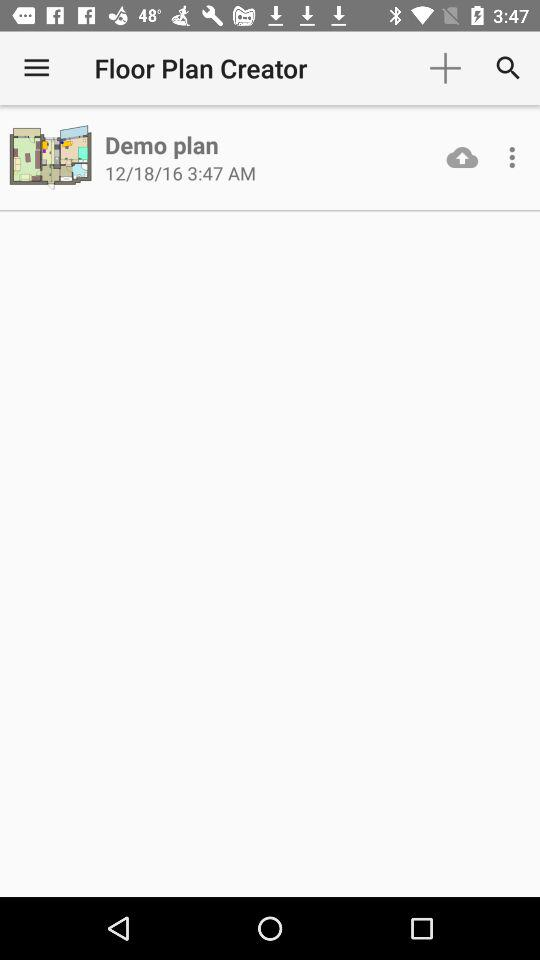What is the date? The date is "12/18/16". 